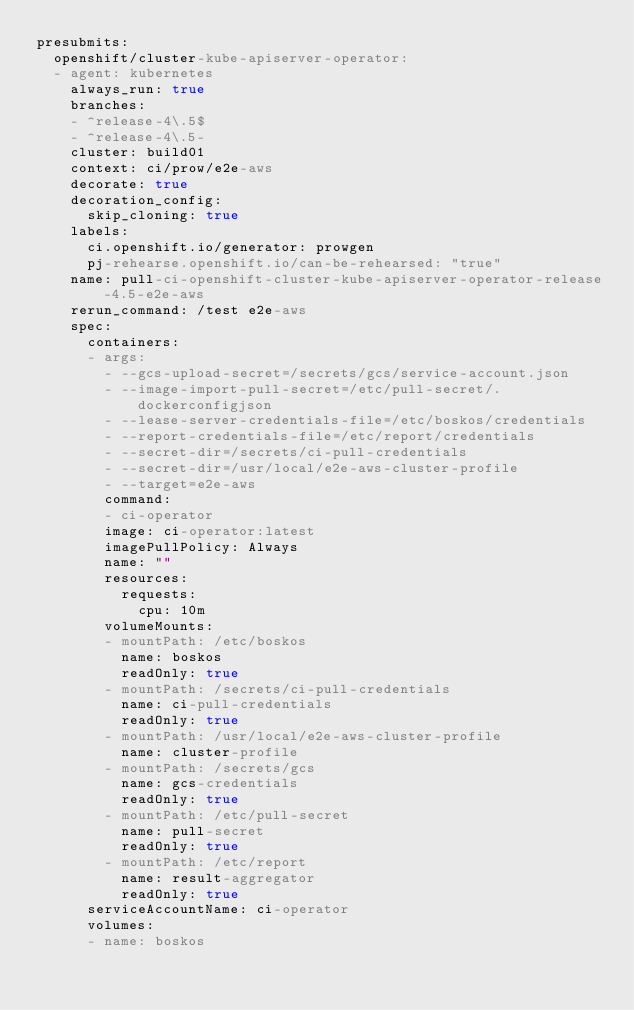<code> <loc_0><loc_0><loc_500><loc_500><_YAML_>presubmits:
  openshift/cluster-kube-apiserver-operator:
  - agent: kubernetes
    always_run: true
    branches:
    - ^release-4\.5$
    - ^release-4\.5-
    cluster: build01
    context: ci/prow/e2e-aws
    decorate: true
    decoration_config:
      skip_cloning: true
    labels:
      ci.openshift.io/generator: prowgen
      pj-rehearse.openshift.io/can-be-rehearsed: "true"
    name: pull-ci-openshift-cluster-kube-apiserver-operator-release-4.5-e2e-aws
    rerun_command: /test e2e-aws
    spec:
      containers:
      - args:
        - --gcs-upload-secret=/secrets/gcs/service-account.json
        - --image-import-pull-secret=/etc/pull-secret/.dockerconfigjson
        - --lease-server-credentials-file=/etc/boskos/credentials
        - --report-credentials-file=/etc/report/credentials
        - --secret-dir=/secrets/ci-pull-credentials
        - --secret-dir=/usr/local/e2e-aws-cluster-profile
        - --target=e2e-aws
        command:
        - ci-operator
        image: ci-operator:latest
        imagePullPolicy: Always
        name: ""
        resources:
          requests:
            cpu: 10m
        volumeMounts:
        - mountPath: /etc/boskos
          name: boskos
          readOnly: true
        - mountPath: /secrets/ci-pull-credentials
          name: ci-pull-credentials
          readOnly: true
        - mountPath: /usr/local/e2e-aws-cluster-profile
          name: cluster-profile
        - mountPath: /secrets/gcs
          name: gcs-credentials
          readOnly: true
        - mountPath: /etc/pull-secret
          name: pull-secret
          readOnly: true
        - mountPath: /etc/report
          name: result-aggregator
          readOnly: true
      serviceAccountName: ci-operator
      volumes:
      - name: boskos</code> 